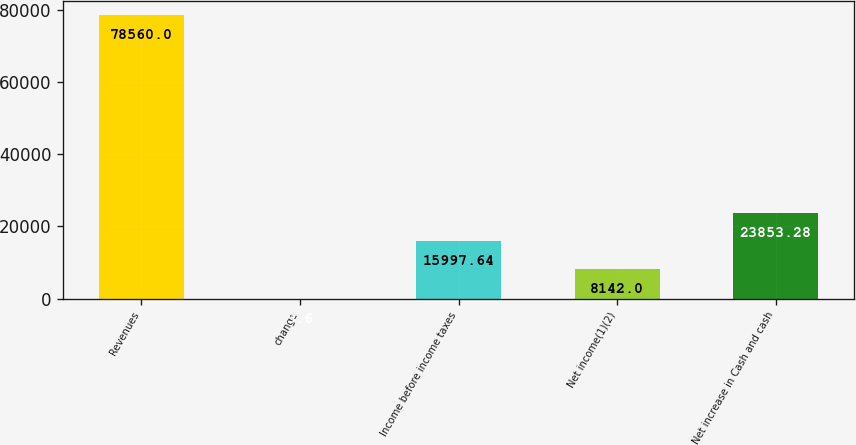Convert chart. <chart><loc_0><loc_0><loc_500><loc_500><bar_chart><fcel>Revenues<fcel>change<fcel>Income before income taxes<fcel>Net income(1)(2)<fcel>Net increase in Cash and cash<nl><fcel>78560<fcel>3.6<fcel>15997.6<fcel>8142<fcel>23853.3<nl></chart> 